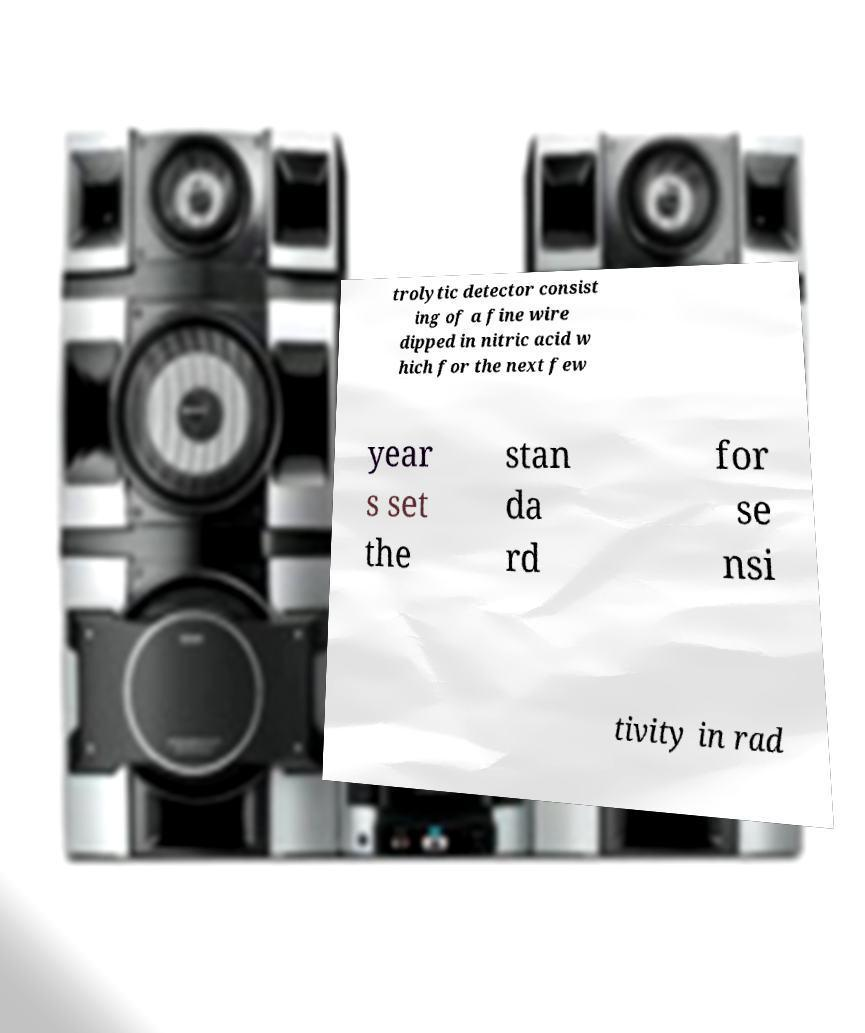For documentation purposes, I need the text within this image transcribed. Could you provide that? trolytic detector consist ing of a fine wire dipped in nitric acid w hich for the next few year s set the stan da rd for se nsi tivity in rad 